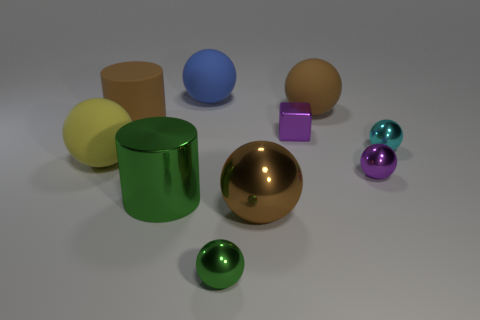What materials do these objects appear to be made of? The objects in the image display a variety of textures suggestive of different materials. The golden sphere in the center has a reflective surface that could be indicative of polished metal. The green cylinder has a similarly reflective quality, possibly also metal but with a colored finish. The matte surfaces of the other objects, such as the yellow and purple ones, may suggest a plastic or painted wood composition. 